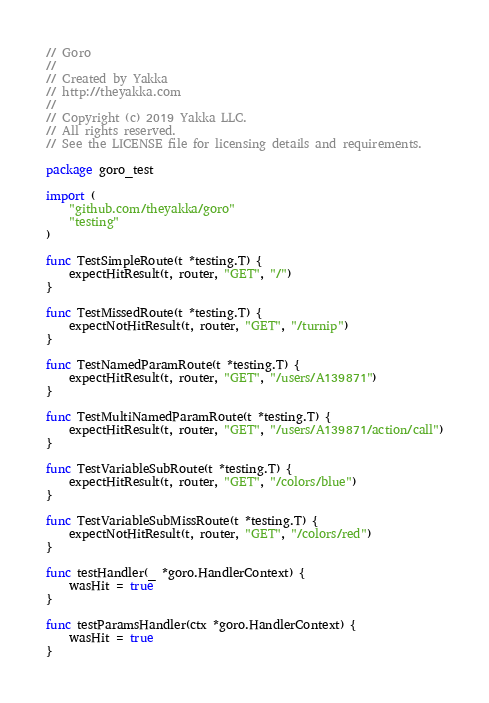Convert code to text. <code><loc_0><loc_0><loc_500><loc_500><_Go_>// Goro
//
// Created by Yakka
// http://theyakka.com
//
// Copyright (c) 2019 Yakka LLC.
// All rights reserved.
// See the LICENSE file for licensing details and requirements.

package goro_test

import (
	"github.com/theyakka/goro"
	"testing"
)

func TestSimpleRoute(t *testing.T) {
	expectHitResult(t, router, "GET", "/")
}

func TestMissedRoute(t *testing.T) {
	expectNotHitResult(t, router, "GET", "/turnip")
}

func TestNamedParamRoute(t *testing.T) {
	expectHitResult(t, router, "GET", "/users/A139871")
}

func TestMultiNamedParamRoute(t *testing.T) {
	expectHitResult(t, router, "GET", "/users/A139871/action/call")
}

func TestVariableSubRoute(t *testing.T) {
	expectHitResult(t, router, "GET", "/colors/blue")
}

func TestVariableSubMissRoute(t *testing.T) {
	expectNotHitResult(t, router, "GET", "/colors/red")
}

func testHandler(_ *goro.HandlerContext) {
	wasHit = true
}

func testParamsHandler(ctx *goro.HandlerContext) {
	wasHit = true
}
</code> 